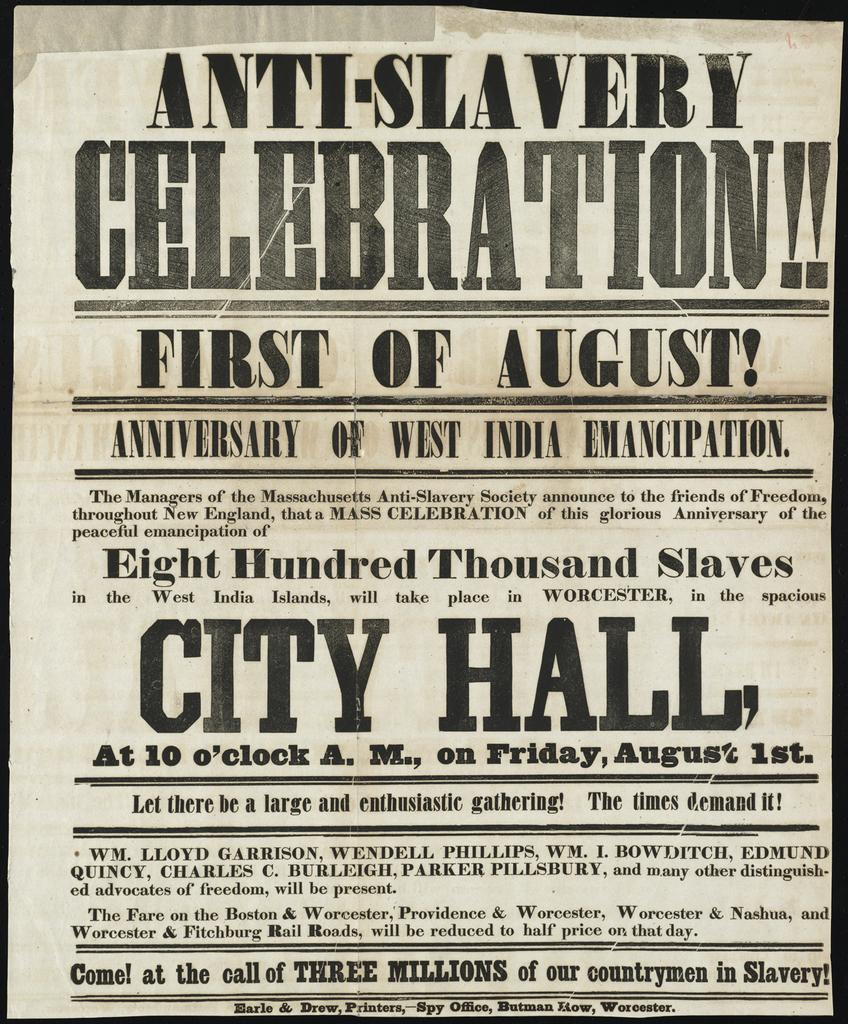<image>
Present a compact description of the photo's key features. Poster saying "Anti-Slavery Celebration" happening on the first of August. 